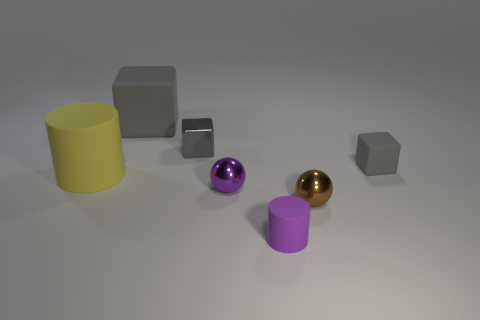Are the shapes in this image forming a particular pattern or sequence? The shapes do not seem to form a specific sequence; they are randomly placed with varying sizes, colors, and types. The arrangement looks more like a casual display than an intentional pattern. 